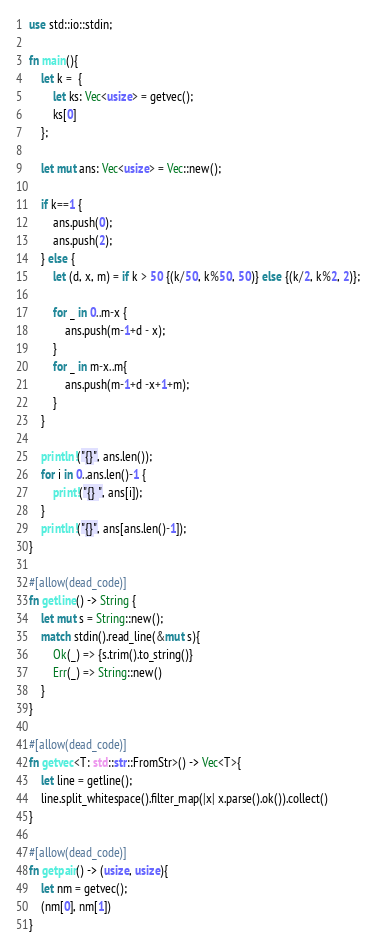Convert code to text. <code><loc_0><loc_0><loc_500><loc_500><_Rust_>use std::io::stdin;

fn main(){
    let k =  {
        let ks: Vec<usize> = getvec();
        ks[0]
    };

    let mut ans: Vec<usize> = Vec::new();

    if k==1 {
        ans.push(0);
        ans.push(2);
    } else {
        let (d, x, m) = if k > 50 {(k/50, k%50, 50)} else {(k/2, k%2, 2)};

        for _ in 0..m-x {
            ans.push(m-1+d - x);
        }
        for _ in m-x..m{
            ans.push(m-1+d -x+1+m);
        }
    }

    println!("{}", ans.len());
    for i in 0..ans.len()-1 {
        print!("{} ", ans[i]);
    }
    println!("{}", ans[ans.len()-1]);
}

#[allow(dead_code)]
fn getline() -> String {
    let mut s = String::new();
    match stdin().read_line(&mut s){
        Ok(_) => {s.trim().to_string()}
        Err(_) => String::new()
    }
}

#[allow(dead_code)]
fn getvec<T: std::str::FromStr>() -> Vec<T>{
    let line = getline();
    line.split_whitespace().filter_map(|x| x.parse().ok()).collect()
}

#[allow(dead_code)]
fn getpair() -> (usize, usize){
    let nm = getvec();
    (nm[0], nm[1])
}
</code> 